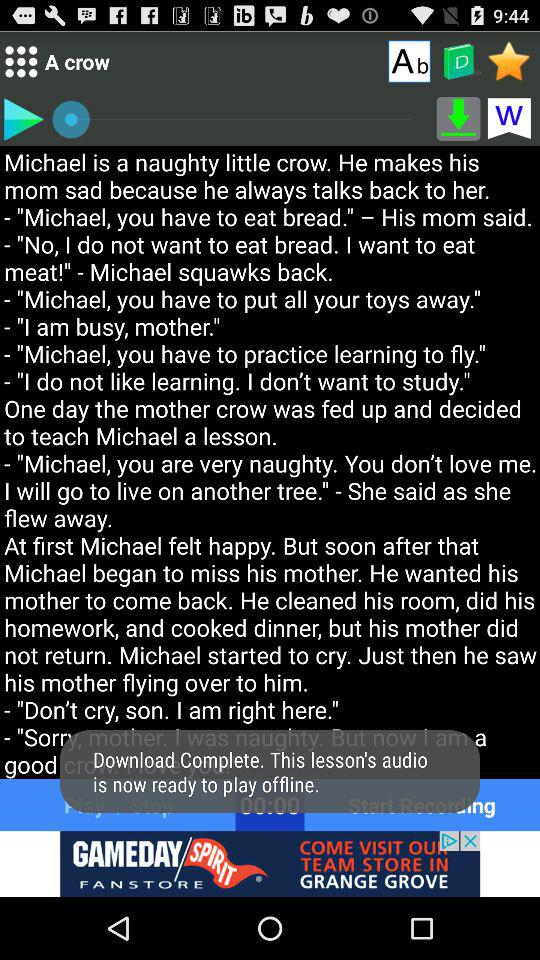What is the title of the lesson? The title of the lesson is "A crow". 